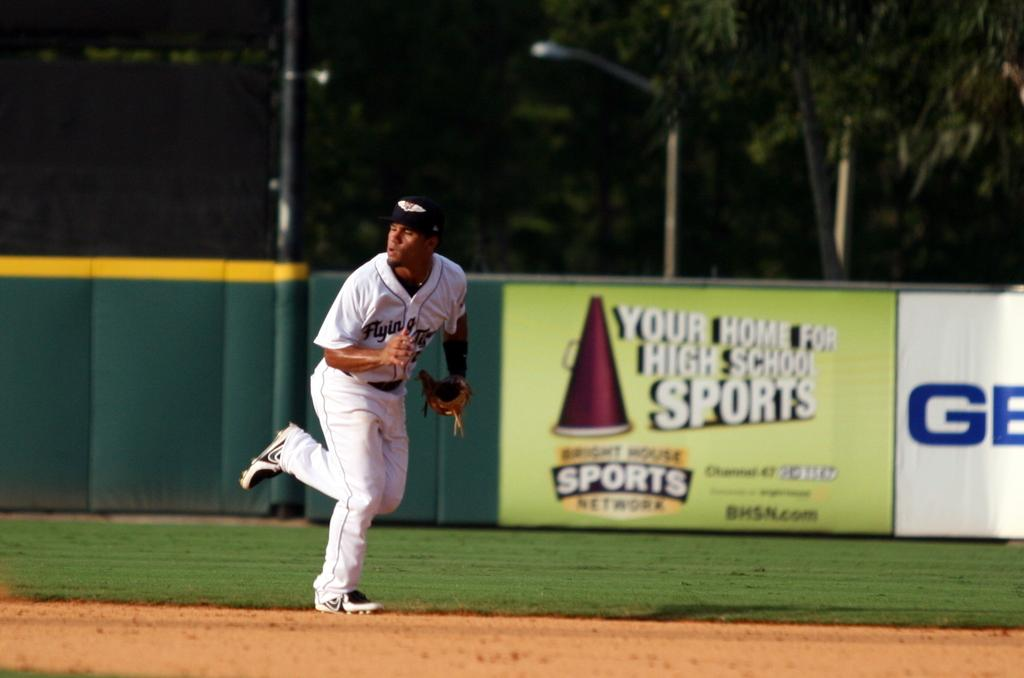Provide a one-sentence caption for the provided image. A player in a white uniform runs in front of a sign with BHSN.com. 